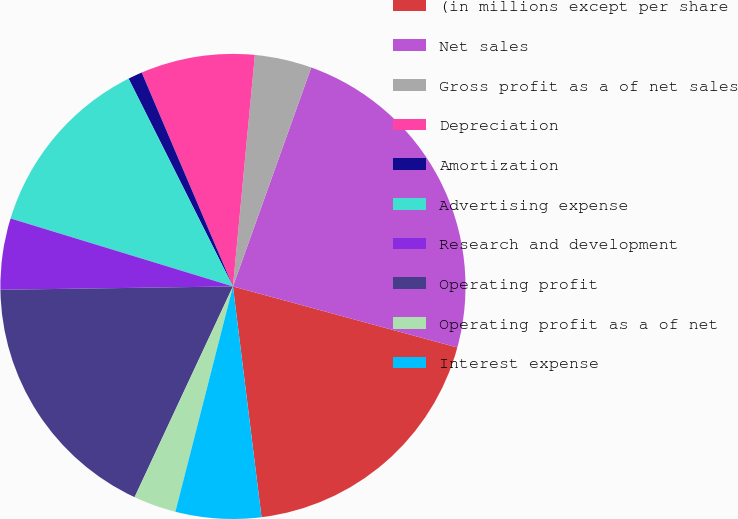<chart> <loc_0><loc_0><loc_500><loc_500><pie_chart><fcel>(in millions except per share<fcel>Net sales<fcel>Gross profit as a of net sales<fcel>Depreciation<fcel>Amortization<fcel>Advertising expense<fcel>Research and development<fcel>Operating profit<fcel>Operating profit as a of net<fcel>Interest expense<nl><fcel>18.81%<fcel>23.76%<fcel>3.96%<fcel>7.92%<fcel>0.99%<fcel>12.87%<fcel>4.95%<fcel>17.82%<fcel>2.97%<fcel>5.94%<nl></chart> 